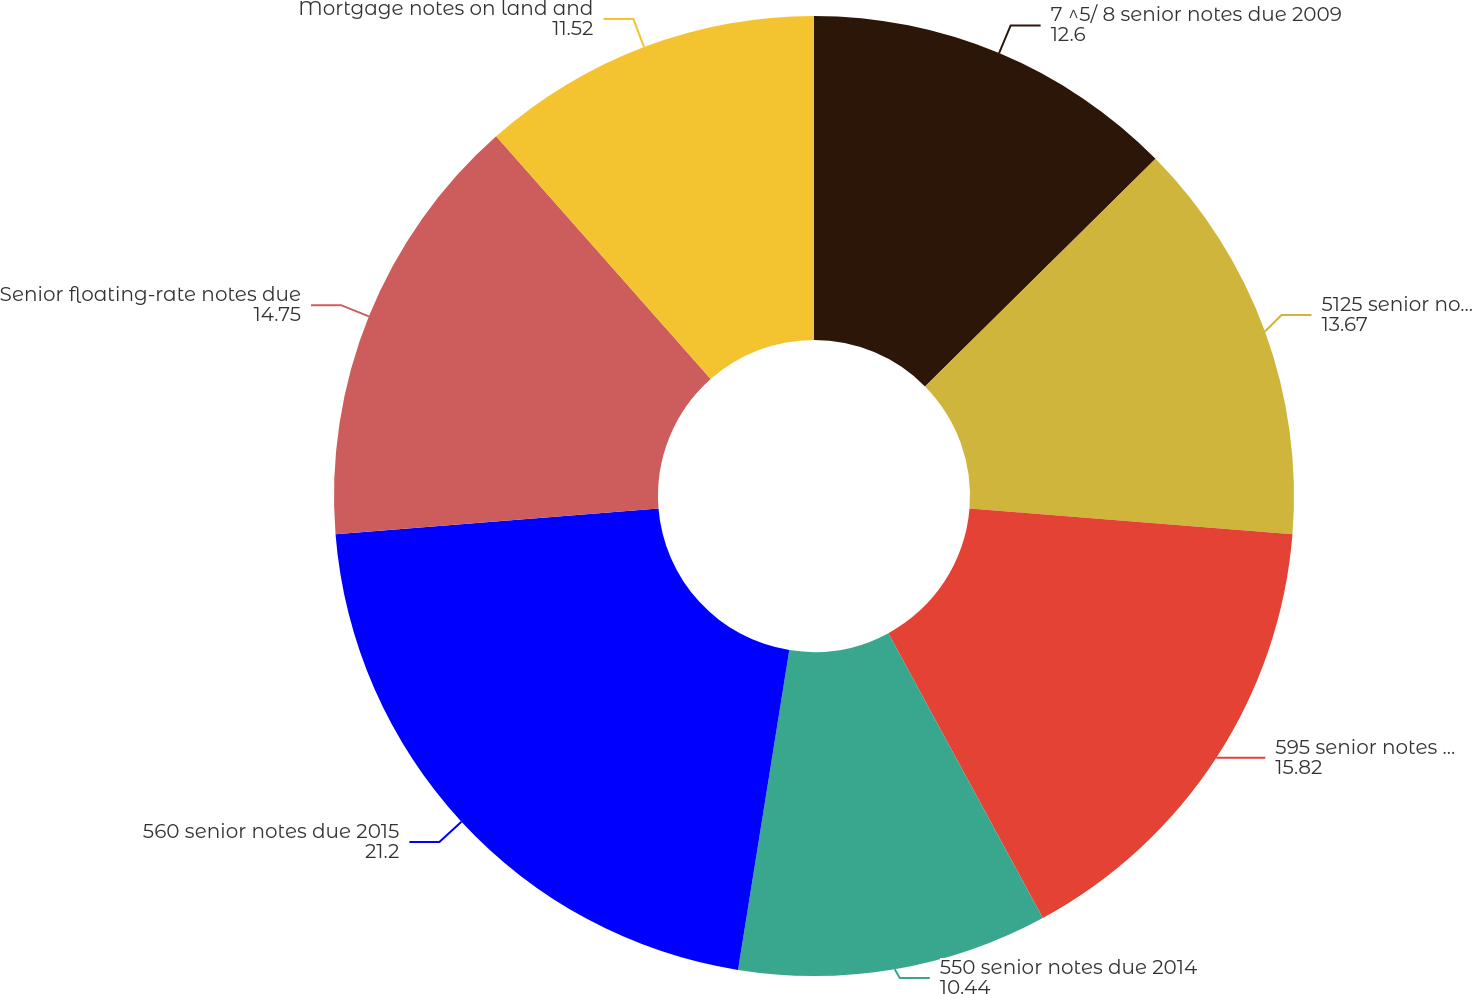<chart> <loc_0><loc_0><loc_500><loc_500><pie_chart><fcel>7 ^5/ 8 senior notes due 2009<fcel>5125 senior notes due 2010<fcel>595 senior notes due 2013<fcel>550 senior notes due 2014<fcel>560 senior notes due 2015<fcel>Senior floating-rate notes due<fcel>Mortgage notes on land and<nl><fcel>12.6%<fcel>13.67%<fcel>15.82%<fcel>10.44%<fcel>21.2%<fcel>14.75%<fcel>11.52%<nl></chart> 